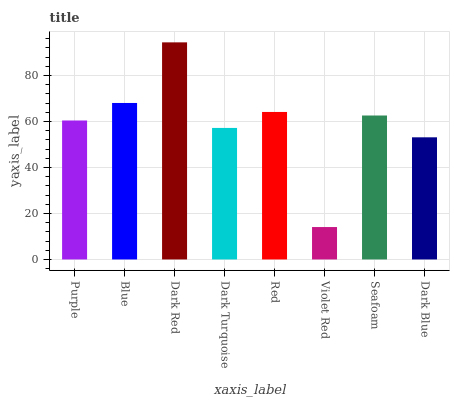Is Blue the minimum?
Answer yes or no. No. Is Blue the maximum?
Answer yes or no. No. Is Blue greater than Purple?
Answer yes or no. Yes. Is Purple less than Blue?
Answer yes or no. Yes. Is Purple greater than Blue?
Answer yes or no. No. Is Blue less than Purple?
Answer yes or no. No. Is Seafoam the high median?
Answer yes or no. Yes. Is Purple the low median?
Answer yes or no. Yes. Is Purple the high median?
Answer yes or no. No. Is Violet Red the low median?
Answer yes or no. No. 